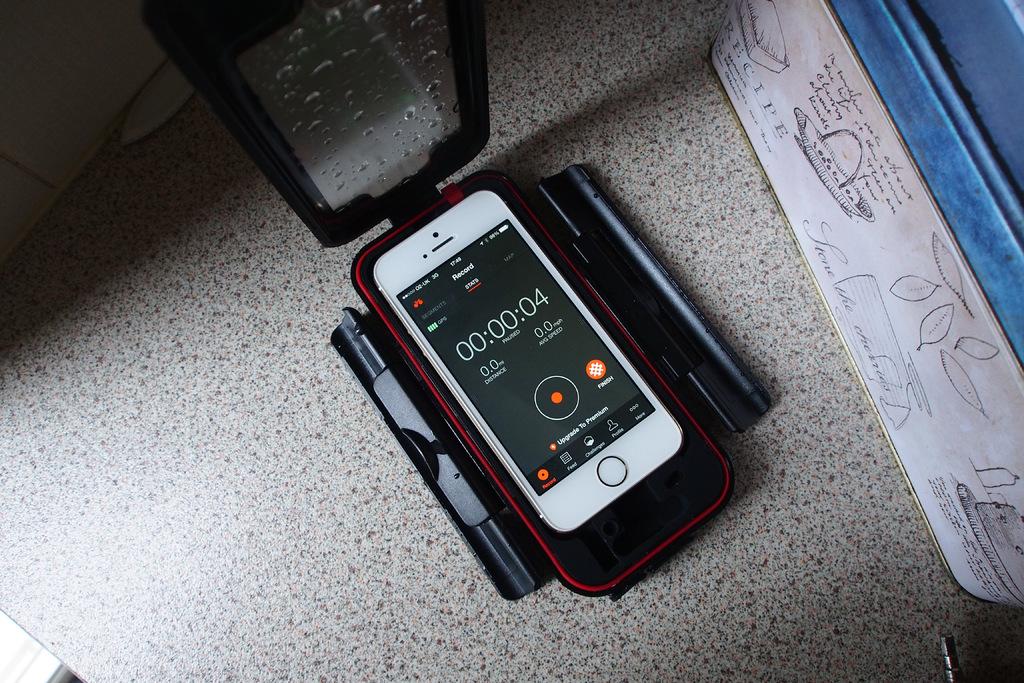How much time is left on the timer?
Keep it short and to the point. 00:00:04. This is mobile phone?
Keep it short and to the point. Yes. 